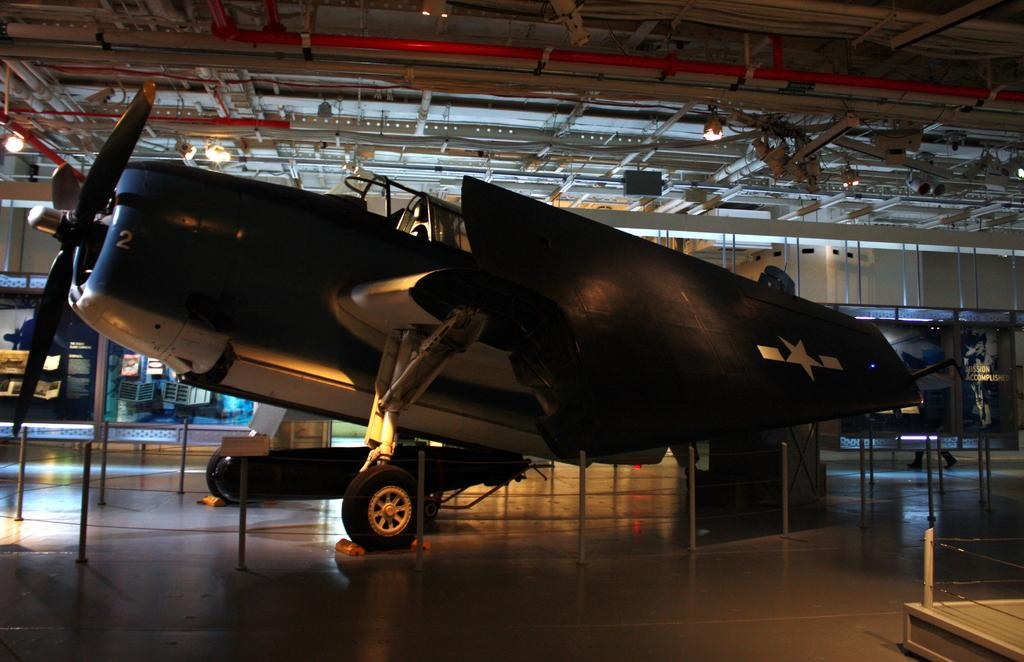What is placed on the floor in the image? There is an airplane on the floor in the image. What other objects can be seen in the image besides the airplane? There are rods, a pole, lights, and a roof in the image. Can you see any thunder in the image? There is no thunder present in the image. Are there any masks visible in the image? There are no masks present in the image. 